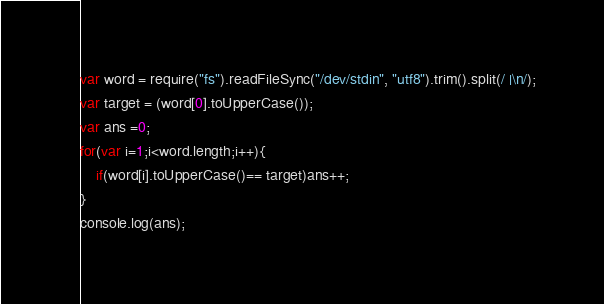Convert code to text. <code><loc_0><loc_0><loc_500><loc_500><_JavaScript_>var word = require("fs").readFileSync("/dev/stdin", "utf8").trim().split(/ |\n/);
var target = (word[0].toUpperCase());
var ans =0;
for(var i=1;i<word.length;i++){
    if(word[i].toUpperCase()== target)ans++;
}
console.log(ans);</code> 